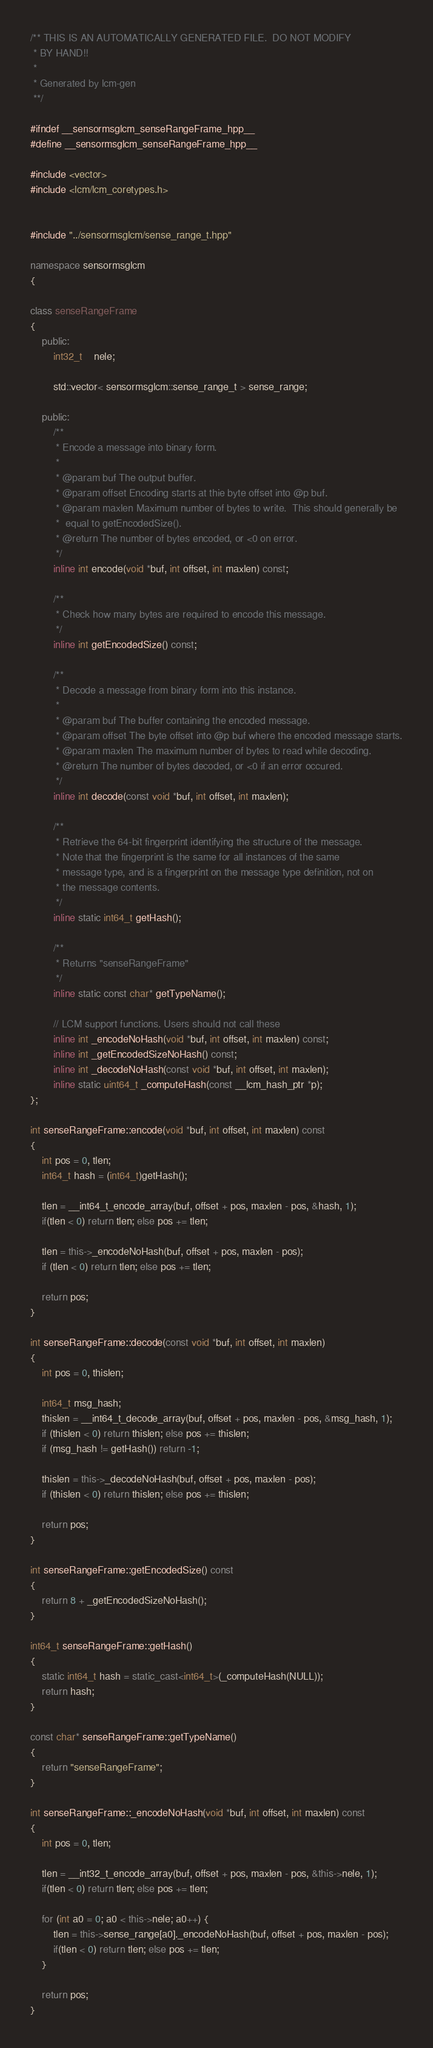<code> <loc_0><loc_0><loc_500><loc_500><_C++_>/** THIS IS AN AUTOMATICALLY GENERATED FILE.  DO NOT MODIFY
 * BY HAND!!
 *
 * Generated by lcm-gen
 **/

#ifndef __sensormsglcm_senseRangeFrame_hpp__
#define __sensormsglcm_senseRangeFrame_hpp__

#include <vector>
#include <lcm/lcm_coretypes.h>


#include "../sensormsglcm/sense_range_t.hpp"

namespace sensormsglcm
{

class senseRangeFrame
{
    public:
        int32_t    nele;

        std::vector< sensormsglcm::sense_range_t > sense_range;

    public:
        /**
         * Encode a message into binary form.
         *
         * @param buf The output buffer.
         * @param offset Encoding starts at thie byte offset into @p buf.
         * @param maxlen Maximum number of bytes to write.  This should generally be
         *  equal to getEncodedSize().
         * @return The number of bytes encoded, or <0 on error.
         */
        inline int encode(void *buf, int offset, int maxlen) const;

        /**
         * Check how many bytes are required to encode this message.
         */
        inline int getEncodedSize() const;

        /**
         * Decode a message from binary form into this instance.
         *
         * @param buf The buffer containing the encoded message.
         * @param offset The byte offset into @p buf where the encoded message starts.
         * @param maxlen The maximum number of bytes to read while decoding.
         * @return The number of bytes decoded, or <0 if an error occured.
         */
        inline int decode(const void *buf, int offset, int maxlen);

        /**
         * Retrieve the 64-bit fingerprint identifying the structure of the message.
         * Note that the fingerprint is the same for all instances of the same
         * message type, and is a fingerprint on the message type definition, not on
         * the message contents.
         */
        inline static int64_t getHash();

        /**
         * Returns "senseRangeFrame"
         */
        inline static const char* getTypeName();

        // LCM support functions. Users should not call these
        inline int _encodeNoHash(void *buf, int offset, int maxlen) const;
        inline int _getEncodedSizeNoHash() const;
        inline int _decodeNoHash(const void *buf, int offset, int maxlen);
        inline static uint64_t _computeHash(const __lcm_hash_ptr *p);
};

int senseRangeFrame::encode(void *buf, int offset, int maxlen) const
{
    int pos = 0, tlen;
    int64_t hash = (int64_t)getHash();

    tlen = __int64_t_encode_array(buf, offset + pos, maxlen - pos, &hash, 1);
    if(tlen < 0) return tlen; else pos += tlen;

    tlen = this->_encodeNoHash(buf, offset + pos, maxlen - pos);
    if (tlen < 0) return tlen; else pos += tlen;

    return pos;
}

int senseRangeFrame::decode(const void *buf, int offset, int maxlen)
{
    int pos = 0, thislen;

    int64_t msg_hash;
    thislen = __int64_t_decode_array(buf, offset + pos, maxlen - pos, &msg_hash, 1);
    if (thislen < 0) return thislen; else pos += thislen;
    if (msg_hash != getHash()) return -1;

    thislen = this->_decodeNoHash(buf, offset + pos, maxlen - pos);
    if (thislen < 0) return thislen; else pos += thislen;

    return pos;
}

int senseRangeFrame::getEncodedSize() const
{
    return 8 + _getEncodedSizeNoHash();
}

int64_t senseRangeFrame::getHash()
{
    static int64_t hash = static_cast<int64_t>(_computeHash(NULL));
    return hash;
}

const char* senseRangeFrame::getTypeName()
{
    return "senseRangeFrame";
}

int senseRangeFrame::_encodeNoHash(void *buf, int offset, int maxlen) const
{
    int pos = 0, tlen;

    tlen = __int32_t_encode_array(buf, offset + pos, maxlen - pos, &this->nele, 1);
    if(tlen < 0) return tlen; else pos += tlen;

    for (int a0 = 0; a0 < this->nele; a0++) {
        tlen = this->sense_range[a0]._encodeNoHash(buf, offset + pos, maxlen - pos);
        if(tlen < 0) return tlen; else pos += tlen;
    }

    return pos;
}
</code> 